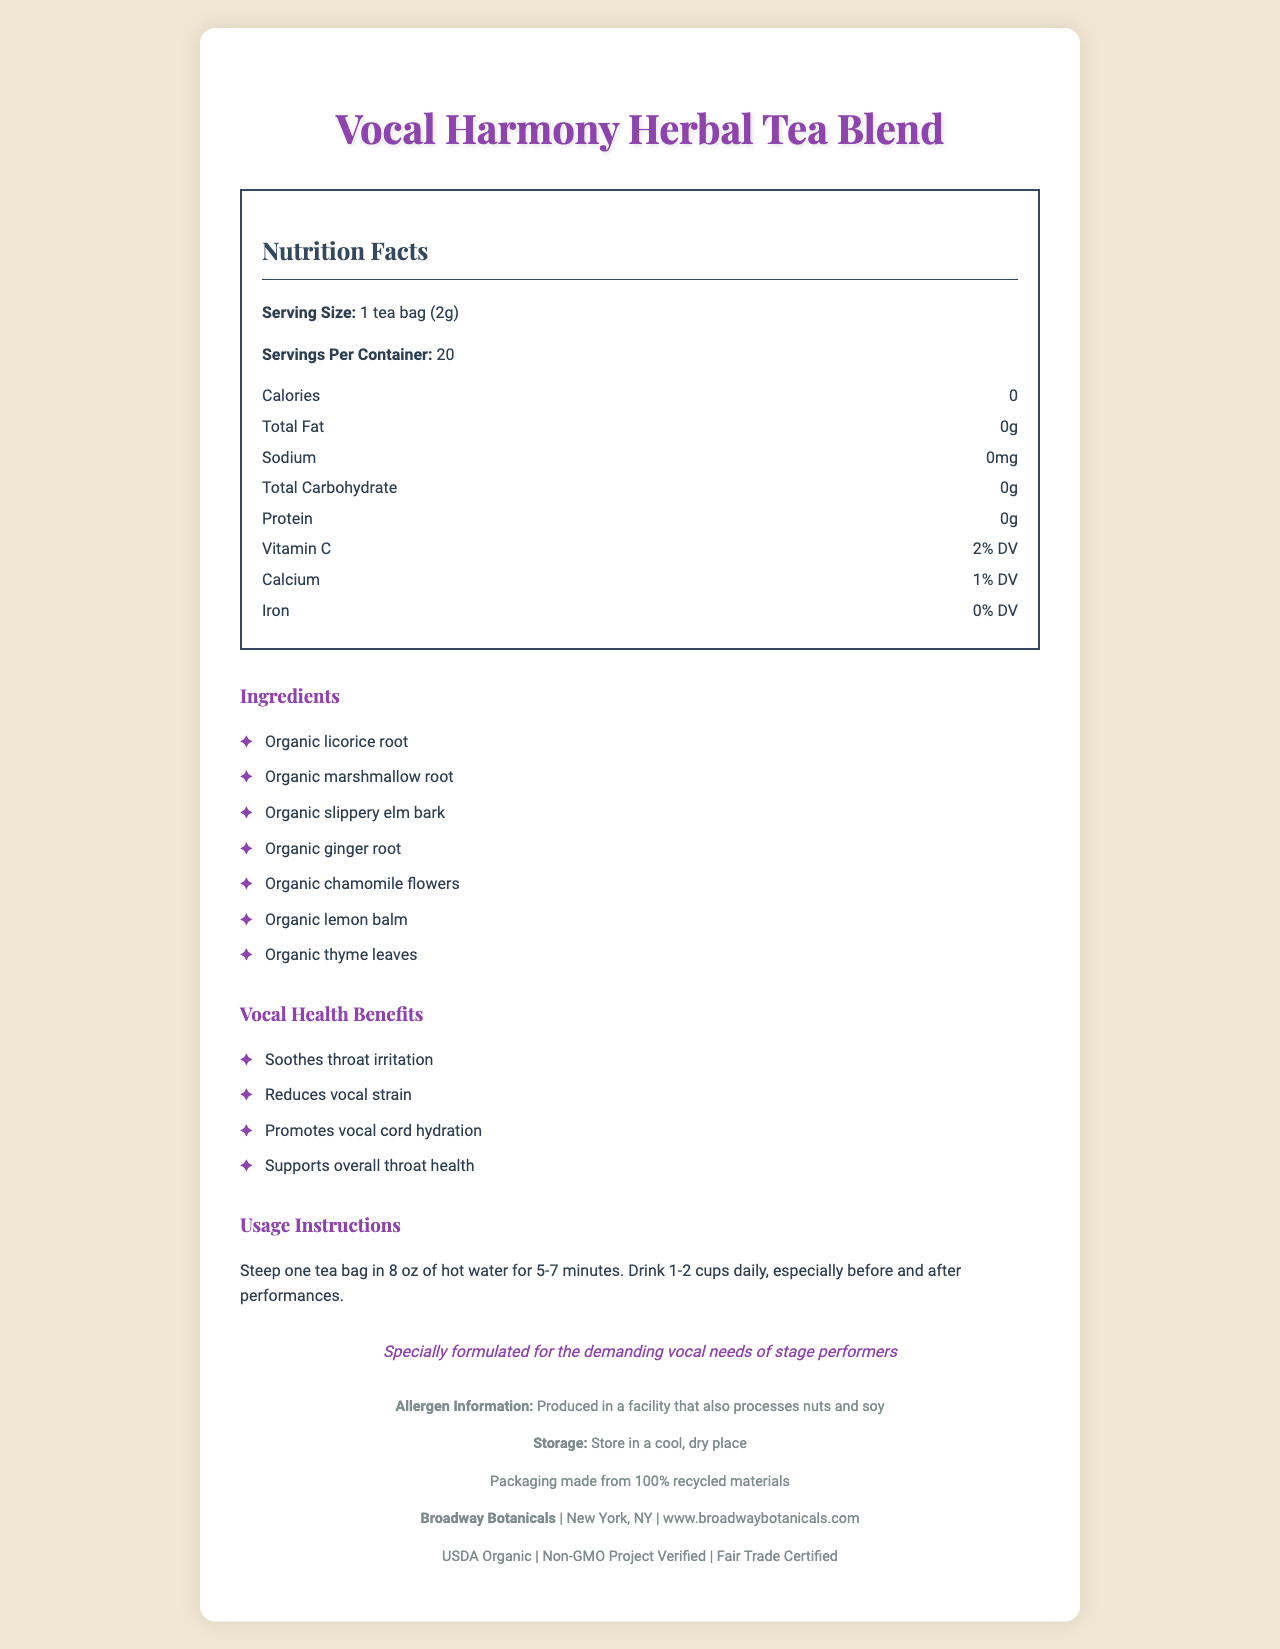what is the product name? The product name is displayed at the top of the document in the title and heading section.
Answer: Vocal Harmony Herbal Tea Blend how many servings per container? The document specifies that there are 20 servings per container under the Nutrition Facts section.
Answer: 20 what is the serving size? The serving size is listed as "1 tea bag (2g)" in the Nutrition Facts section.
Answer: 1 tea bag (2g) which vitamin is present, and what is its Daily Value percentage? The presence and Daily Value of Vitamin C are specified in the Nutrition Facts section, indicating that it is 2% of the Daily Value.
Answer: Vitamin C, 2% DV what are the main vocal health benefits? The document lists these benefits under the "Vocal Health Benefits" section.
Answer: Soothes throat irritation, Reduces vocal strain, Promotes vocal cord hydration, Supports overall throat health which root ingredients are included in the tea blend? A. Organic licorice root, Organic ginger root B. Organic licorice root, Organic marshmallow root, Organic ginger root C. Organic licorice root, Organic slippery elm bark, Organic ginger root The Ingredients section mentions "Organic licorice root," "Organic marshmallow root," and "Organic ginger root."
Answer: B. Organic licorice root, Organic marshmallow root, Organic ginger root what are the steeping instructions for the tea? The Usage Instructions section advises to steep one tea bag in 8 oz of hot water for 5-7 minutes.
Answer: Steep one tea bag in 8 oz of hot water for 5-7 minutes. what is the address of the company? A. Los Angeles, CA B. New York, NY C. San Francisco, CA D. Chicago, IL The document lists "New York, NY" as the company's location under the company information section.
Answer: B. New York, NY does the tea contain any protein? The Nutrition Facts section shows that the tea contains 0g of protein.
Answer: No can it be determined if the tea blend is gluten-free? The document does not provide information on whether the tea blend is gluten-free.
Answer: Not enough information is the packaging environmentally friendly? The document mentions that the packaging is made from 100% recycled materials under the sustainability statement.
Answer: Yes describe the main idea of the document The document presents an overview of the product’s features, benefits, and relevant information to help consumers understand its use and health advantages, especially focusing on vocal health.
Answer: The document provides detailed information about the Vocal Harmony Herbal Tea Blend, including its nutrition facts, ingredients, vocal health benefits, usage instructions, allergen information, storage instructions, company details, and sustainability certifications. It is specifically formulated to support the vocal health needs of stage performers. 